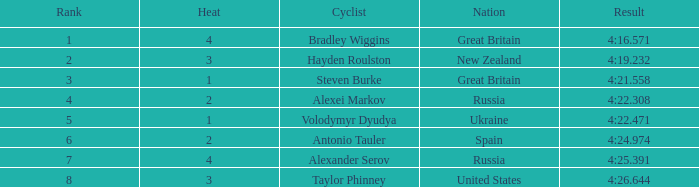What is the lowest standing that spain reached? 6.0. 